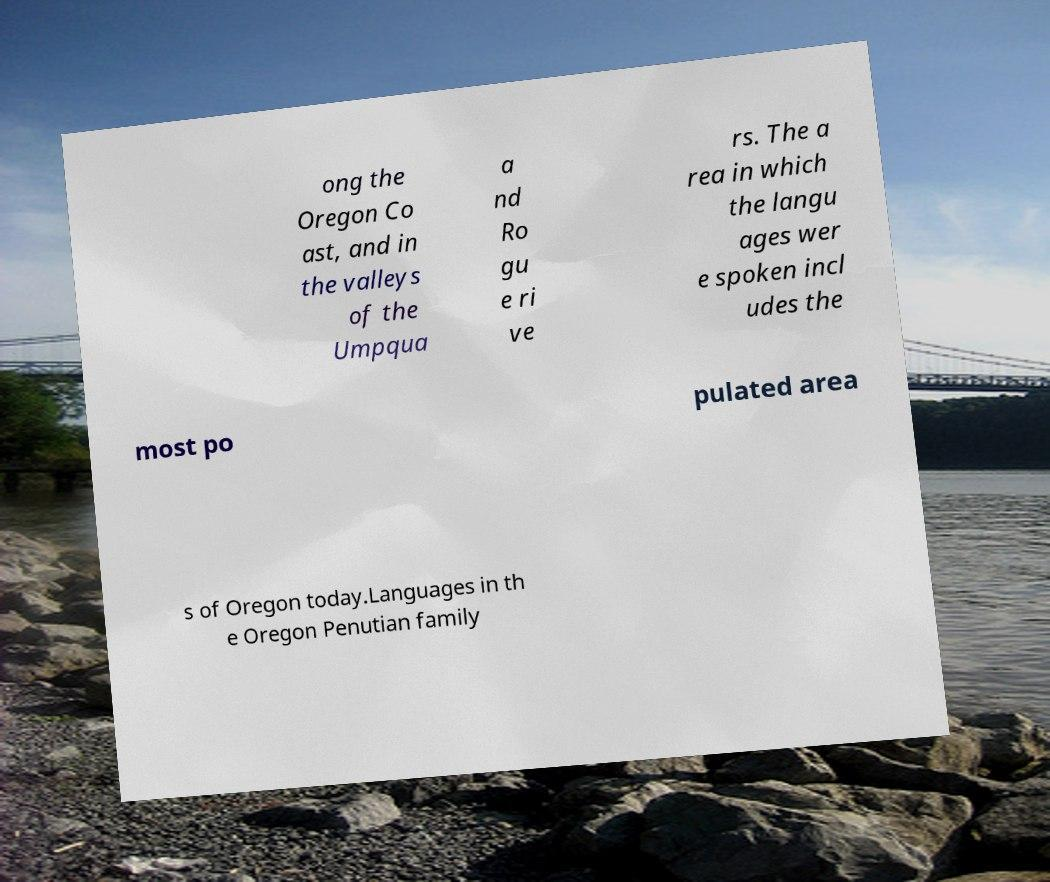Can you read and provide the text displayed in the image?This photo seems to have some interesting text. Can you extract and type it out for me? ong the Oregon Co ast, and in the valleys of the Umpqua a nd Ro gu e ri ve rs. The a rea in which the langu ages wer e spoken incl udes the most po pulated area s of Oregon today.Languages in th e Oregon Penutian family 